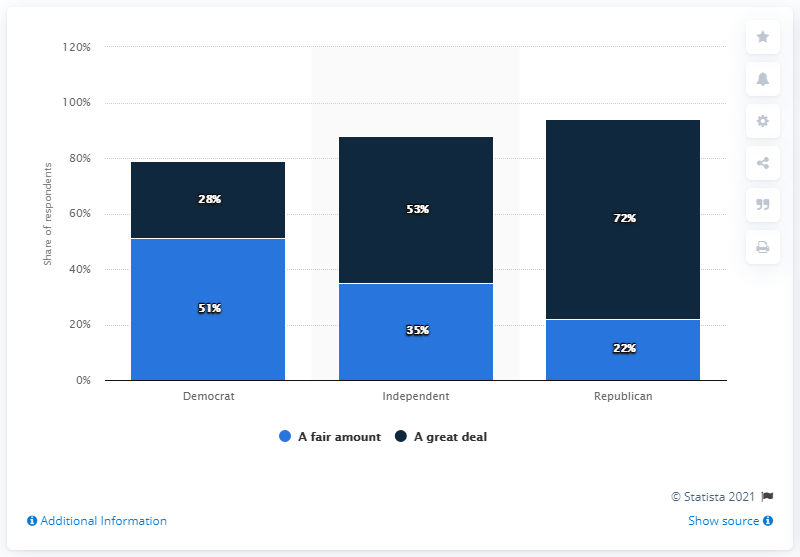Mention a couple of crucial points in this snapshot. The Republican party is more politically biased. The sum of two blocks for the Democrats is 79. 